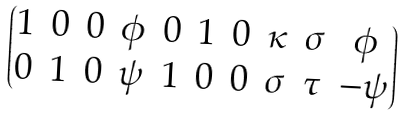Convert formula to latex. <formula><loc_0><loc_0><loc_500><loc_500>\begin{pmatrix} 1 & 0 & 0 & \phi & 0 & 1 & 0 & \kappa & \sigma & \phi \\ 0 & 1 & 0 & \psi & 1 & 0 & 0 & \sigma & \tau & - \psi \end{pmatrix}</formula> 